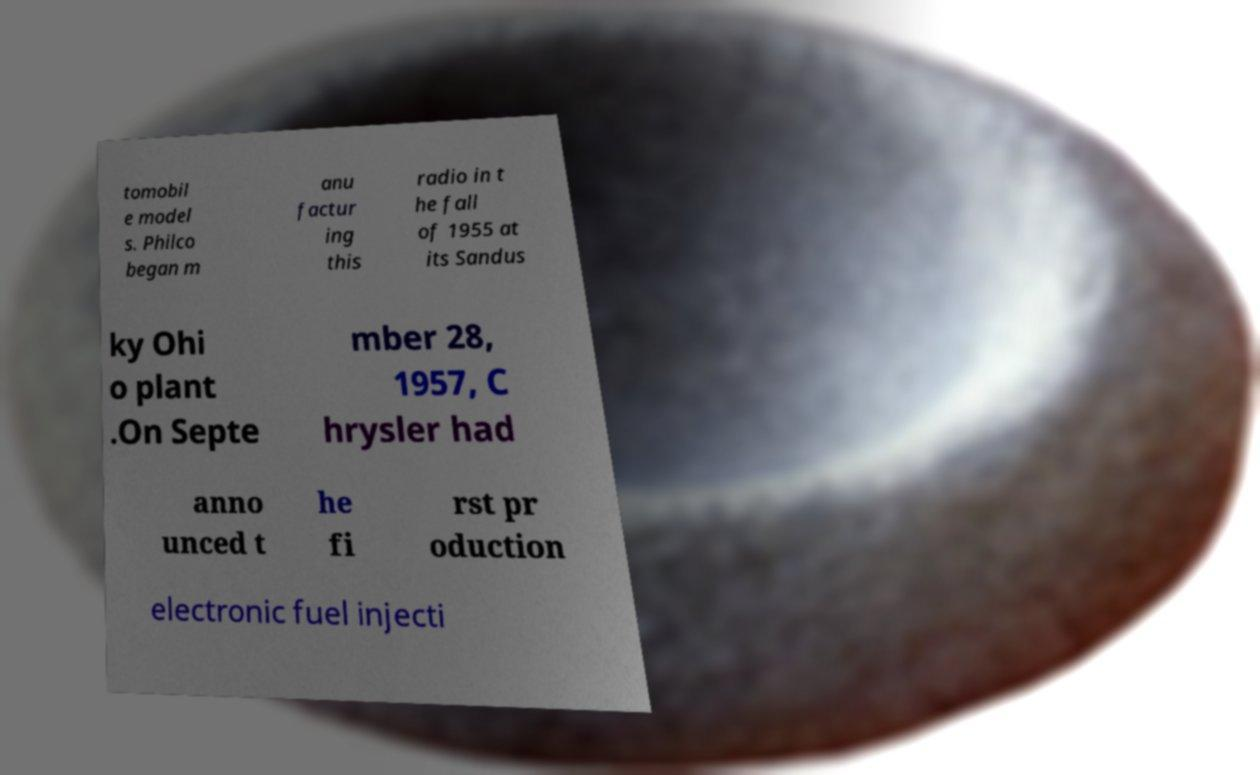Please identify and transcribe the text found in this image. tomobil e model s. Philco began m anu factur ing this radio in t he fall of 1955 at its Sandus ky Ohi o plant .On Septe mber 28, 1957, C hrysler had anno unced t he fi rst pr oduction electronic fuel injecti 